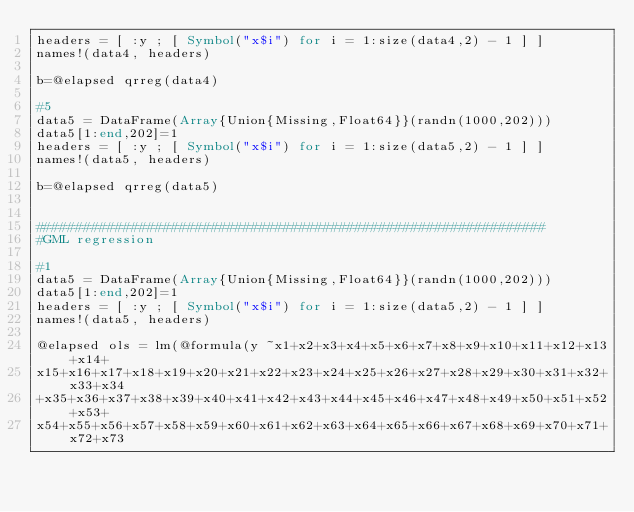<code> <loc_0><loc_0><loc_500><loc_500><_Julia_>headers = [ :y ; [ Symbol("x$i") for i = 1:size(data4,2) - 1 ] ]
names!(data4, headers)

b=@elapsed qrreg(data4)

#5
data5 = DataFrame(Array{Union{Missing,Float64}}(randn(1000,202)))
data5[1:end,202]=1
headers = [ :y ; [ Symbol("x$i") for i = 1:size(data5,2) - 1 ] ]
names!(data5, headers)

b=@elapsed qrreg(data5)


################################################################
#GML regression

#1
data5 = DataFrame(Array{Union{Missing,Float64}}(randn(1000,202)))
data5[1:end,202]=1
headers = [ :y ; [ Symbol("x$i") for i = 1:size(data5,2) - 1 ] ]
names!(data5, headers)

@elapsed ols = lm(@formula(y ~x1+x2+x3+x4+x5+x6+x7+x8+x9+x10+x11+x12+x13+x14+
x15+x16+x17+x18+x19+x20+x21+x22+x23+x24+x25+x26+x27+x28+x29+x30+x31+x32+x33+x34
+x35+x36+x37+x38+x39+x40+x41+x42+x43+x44+x45+x46+x47+x48+x49+x50+x51+x52+x53+
x54+x55+x56+x57+x58+x59+x60+x61+x62+x63+x64+x65+x66+x67+x68+x69+x70+x71+x72+x73</code> 